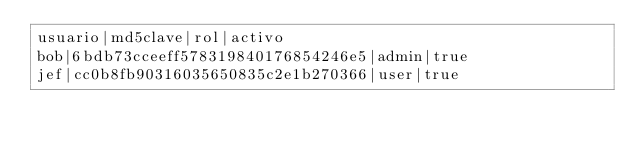Convert code to text. <code><loc_0><loc_0><loc_500><loc_500><_SQL_>usuario|md5clave|rol|activo
bob|6bdb73cceeff578319840176854246e5|admin|true
jef|cc0b8fb90316035650835c2e1b270366|user|true</code> 